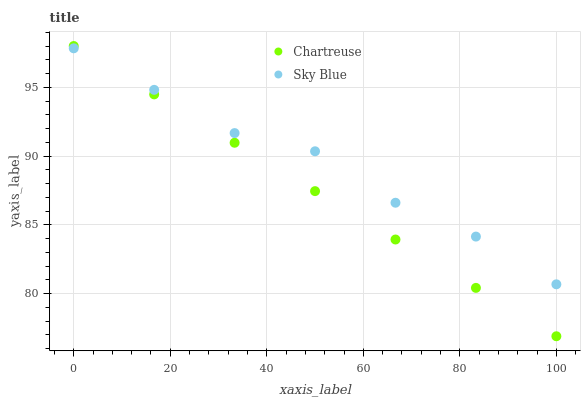Does Chartreuse have the minimum area under the curve?
Answer yes or no. Yes. Does Sky Blue have the maximum area under the curve?
Answer yes or no. Yes. Does Chartreuse have the maximum area under the curve?
Answer yes or no. No. Is Chartreuse the smoothest?
Answer yes or no. Yes. Is Sky Blue the roughest?
Answer yes or no. Yes. Is Chartreuse the roughest?
Answer yes or no. No. Does Chartreuse have the lowest value?
Answer yes or no. Yes. Does Chartreuse have the highest value?
Answer yes or no. Yes. Does Chartreuse intersect Sky Blue?
Answer yes or no. Yes. Is Chartreuse less than Sky Blue?
Answer yes or no. No. Is Chartreuse greater than Sky Blue?
Answer yes or no. No. 